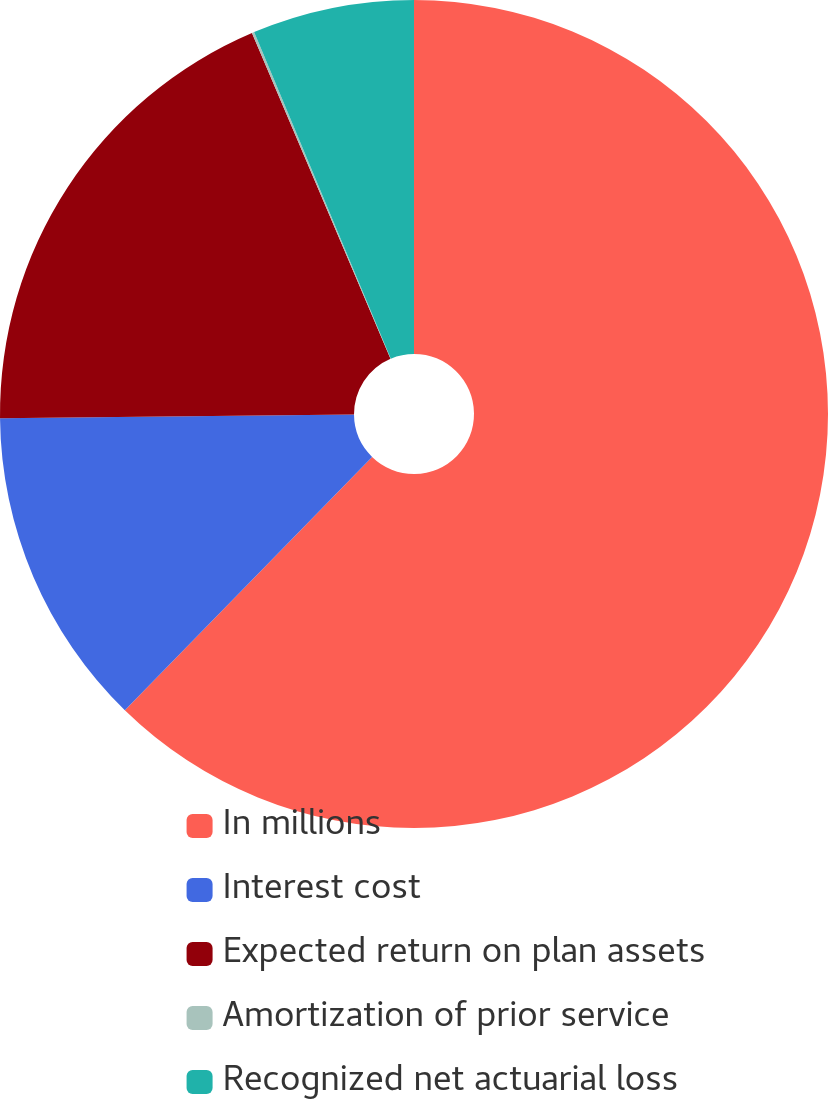Convert chart. <chart><loc_0><loc_0><loc_500><loc_500><pie_chart><fcel>In millions<fcel>Interest cost<fcel>Expected return on plan assets<fcel>Amortization of prior service<fcel>Recognized net actuarial loss<nl><fcel>62.3%<fcel>12.53%<fcel>18.76%<fcel>0.09%<fcel>6.31%<nl></chart> 